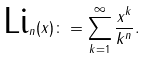Convert formula to latex. <formula><loc_0><loc_0><loc_500><loc_500>\text {Li} _ { n } ( x ) \colon = \sum _ { k = 1 } ^ { \infty } \frac { x ^ { k } } { k ^ { n } } .</formula> 